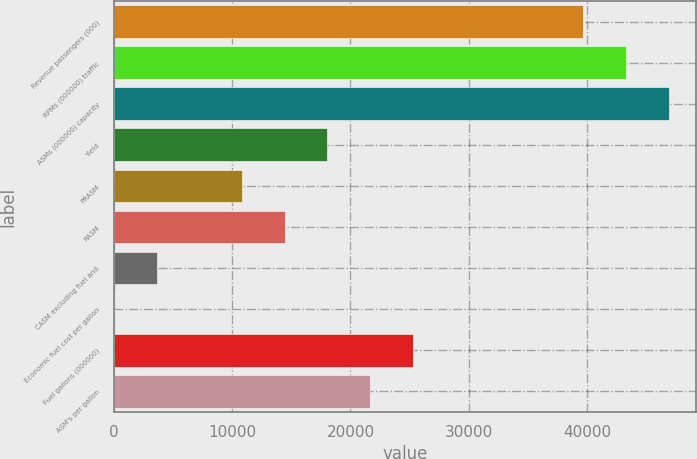Convert chart. <chart><loc_0><loc_0><loc_500><loc_500><bar_chart><fcel>Revenue passengers (000)<fcel>RPMs (000000) traffic<fcel>ASMs (000000) capacity<fcel>Yield<fcel>PRASM<fcel>RASM<fcel>CASM excluding fuel and<fcel>Economic fuel cost per gallon<fcel>Fuel gallons (000000)<fcel>ASM's per gallon<nl><fcel>39685.5<fcel>43293<fcel>46900.4<fcel>18040.5<fcel>10825.5<fcel>14433<fcel>3610.57<fcel>3.08<fcel>25255.5<fcel>21648<nl></chart> 